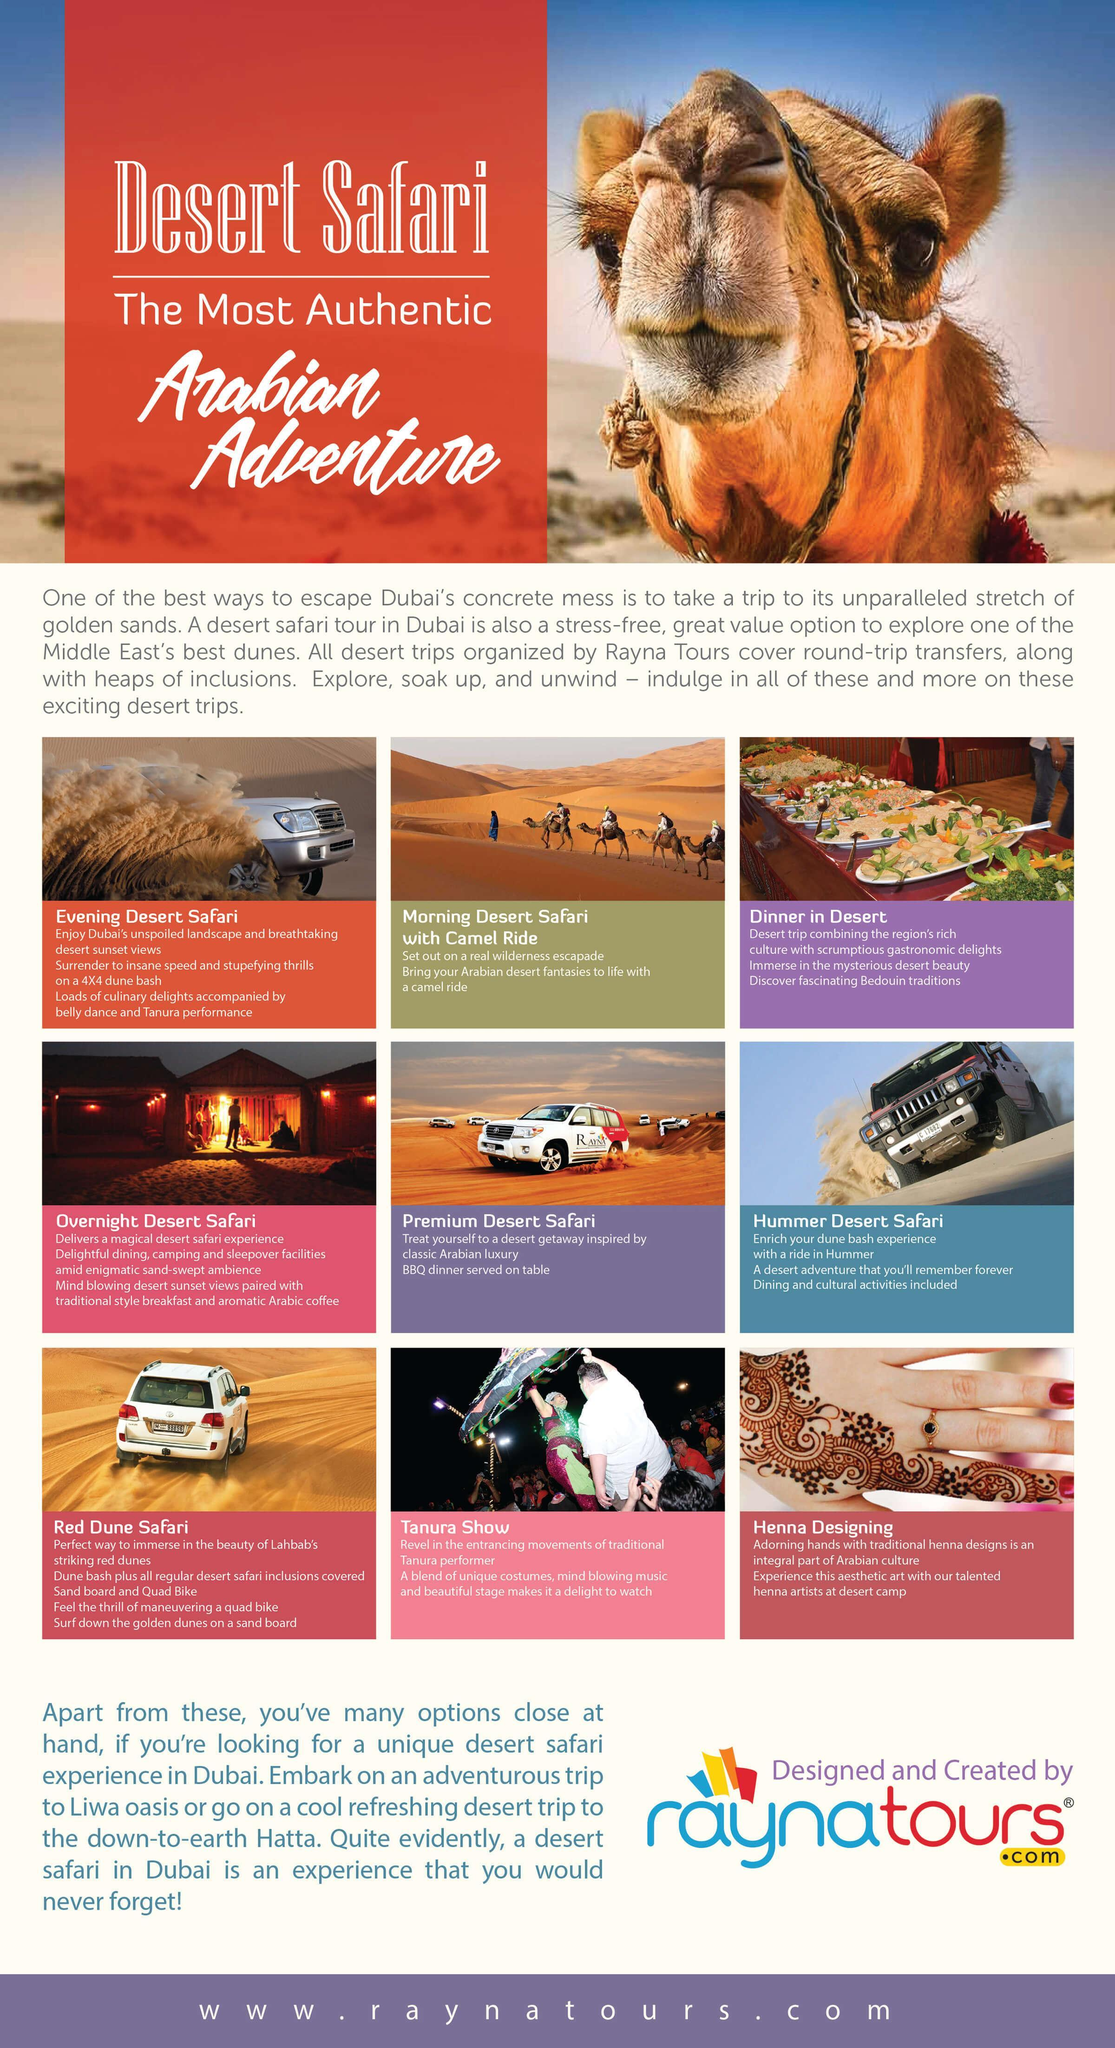Which animal is shown beside Arabian Adventure
Answer the question with a short phrase. Camel Where is Red Dune Safari arranged Lahbab Other that Safari, what are the other activities shown in the brochure Dinner in Desert, Tanura Show, Henna Designing As per picture, where are sleepover facilities arranged in overnight desert safari, tent or flat tent How many types of Desert Safari has been mentioned 6 In which safari is BBQ dinner serves on table Premium Desert Safari 